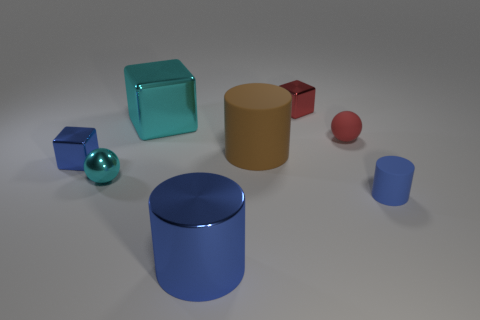Add 1 blue metal cubes. How many objects exist? 9 Subtract all cylinders. How many objects are left? 5 Add 6 tiny cyan metal spheres. How many tiny cyan metal spheres exist? 7 Subtract 1 red spheres. How many objects are left? 7 Subtract all yellow rubber cubes. Subtract all tiny balls. How many objects are left? 6 Add 3 tiny rubber cylinders. How many tiny rubber cylinders are left? 4 